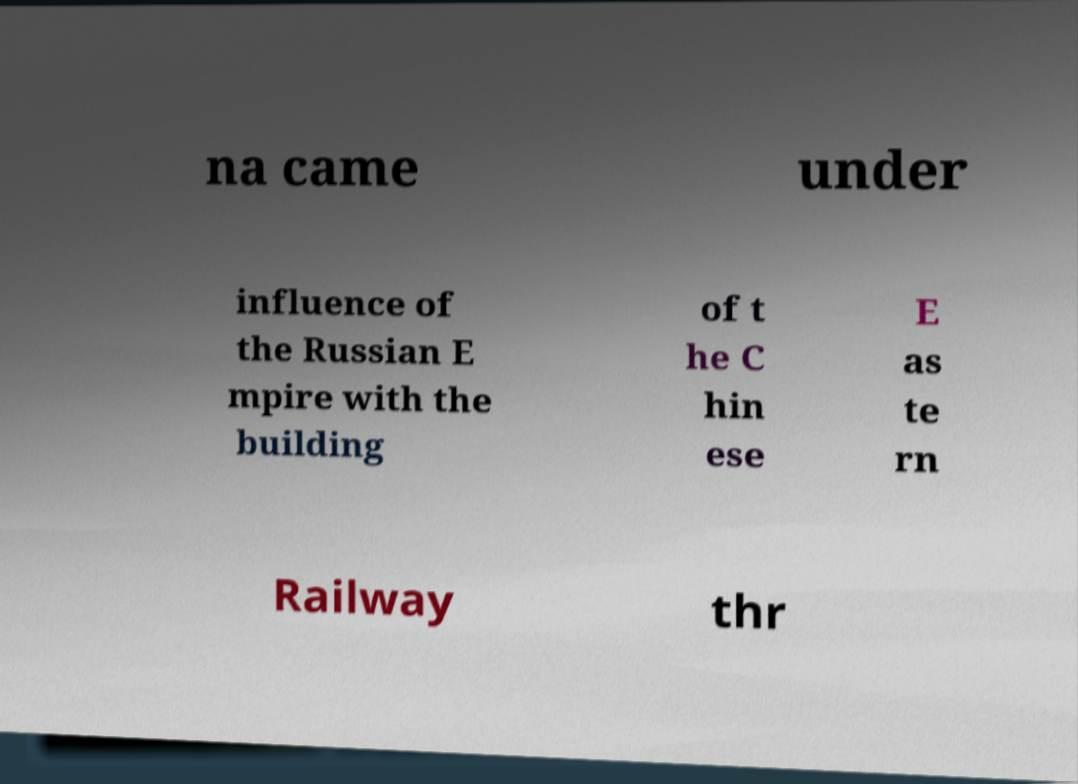Please identify and transcribe the text found in this image. na came under influence of the Russian E mpire with the building of t he C hin ese E as te rn Railway thr 